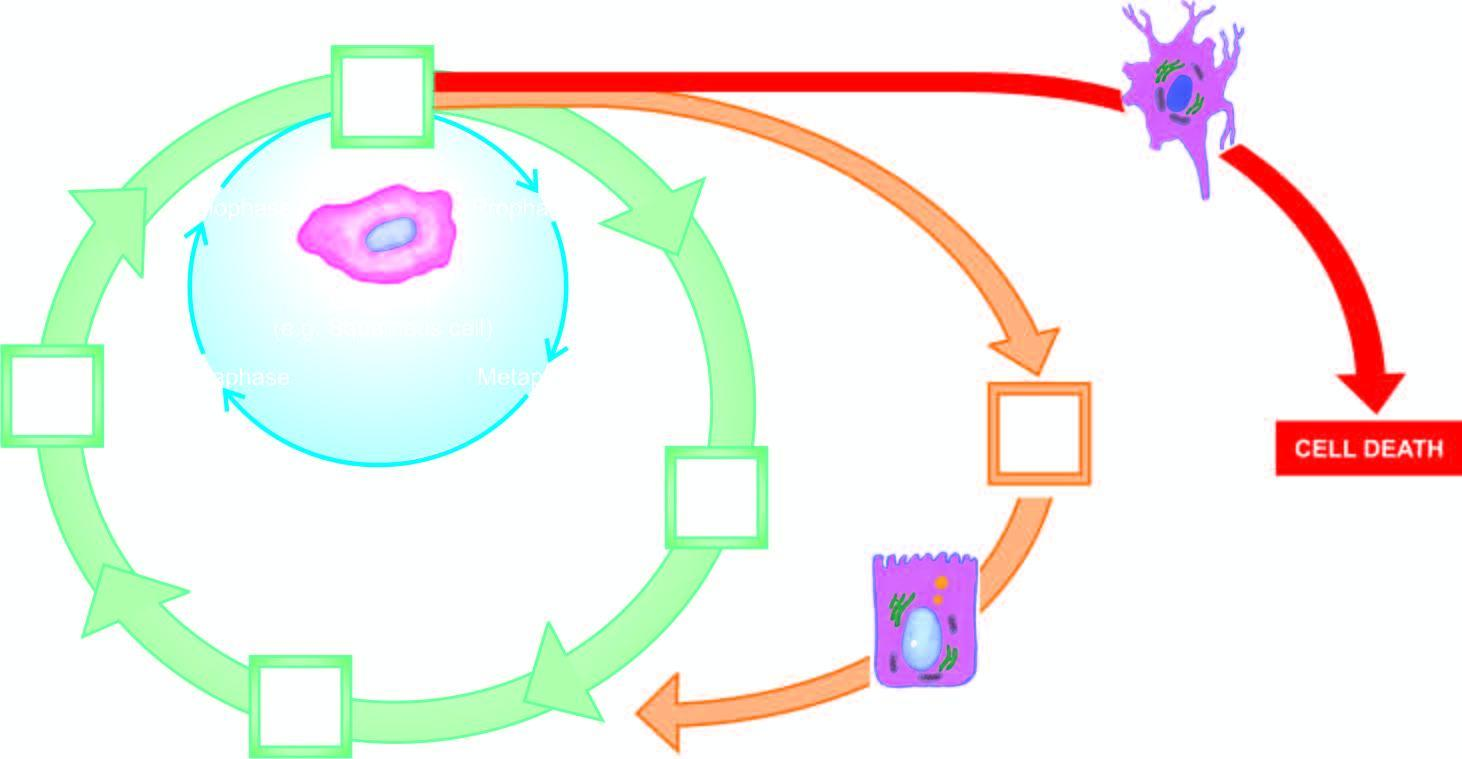does amyloid represent cell cycle for labile cells?
Answer the question using a single word or phrase. No 